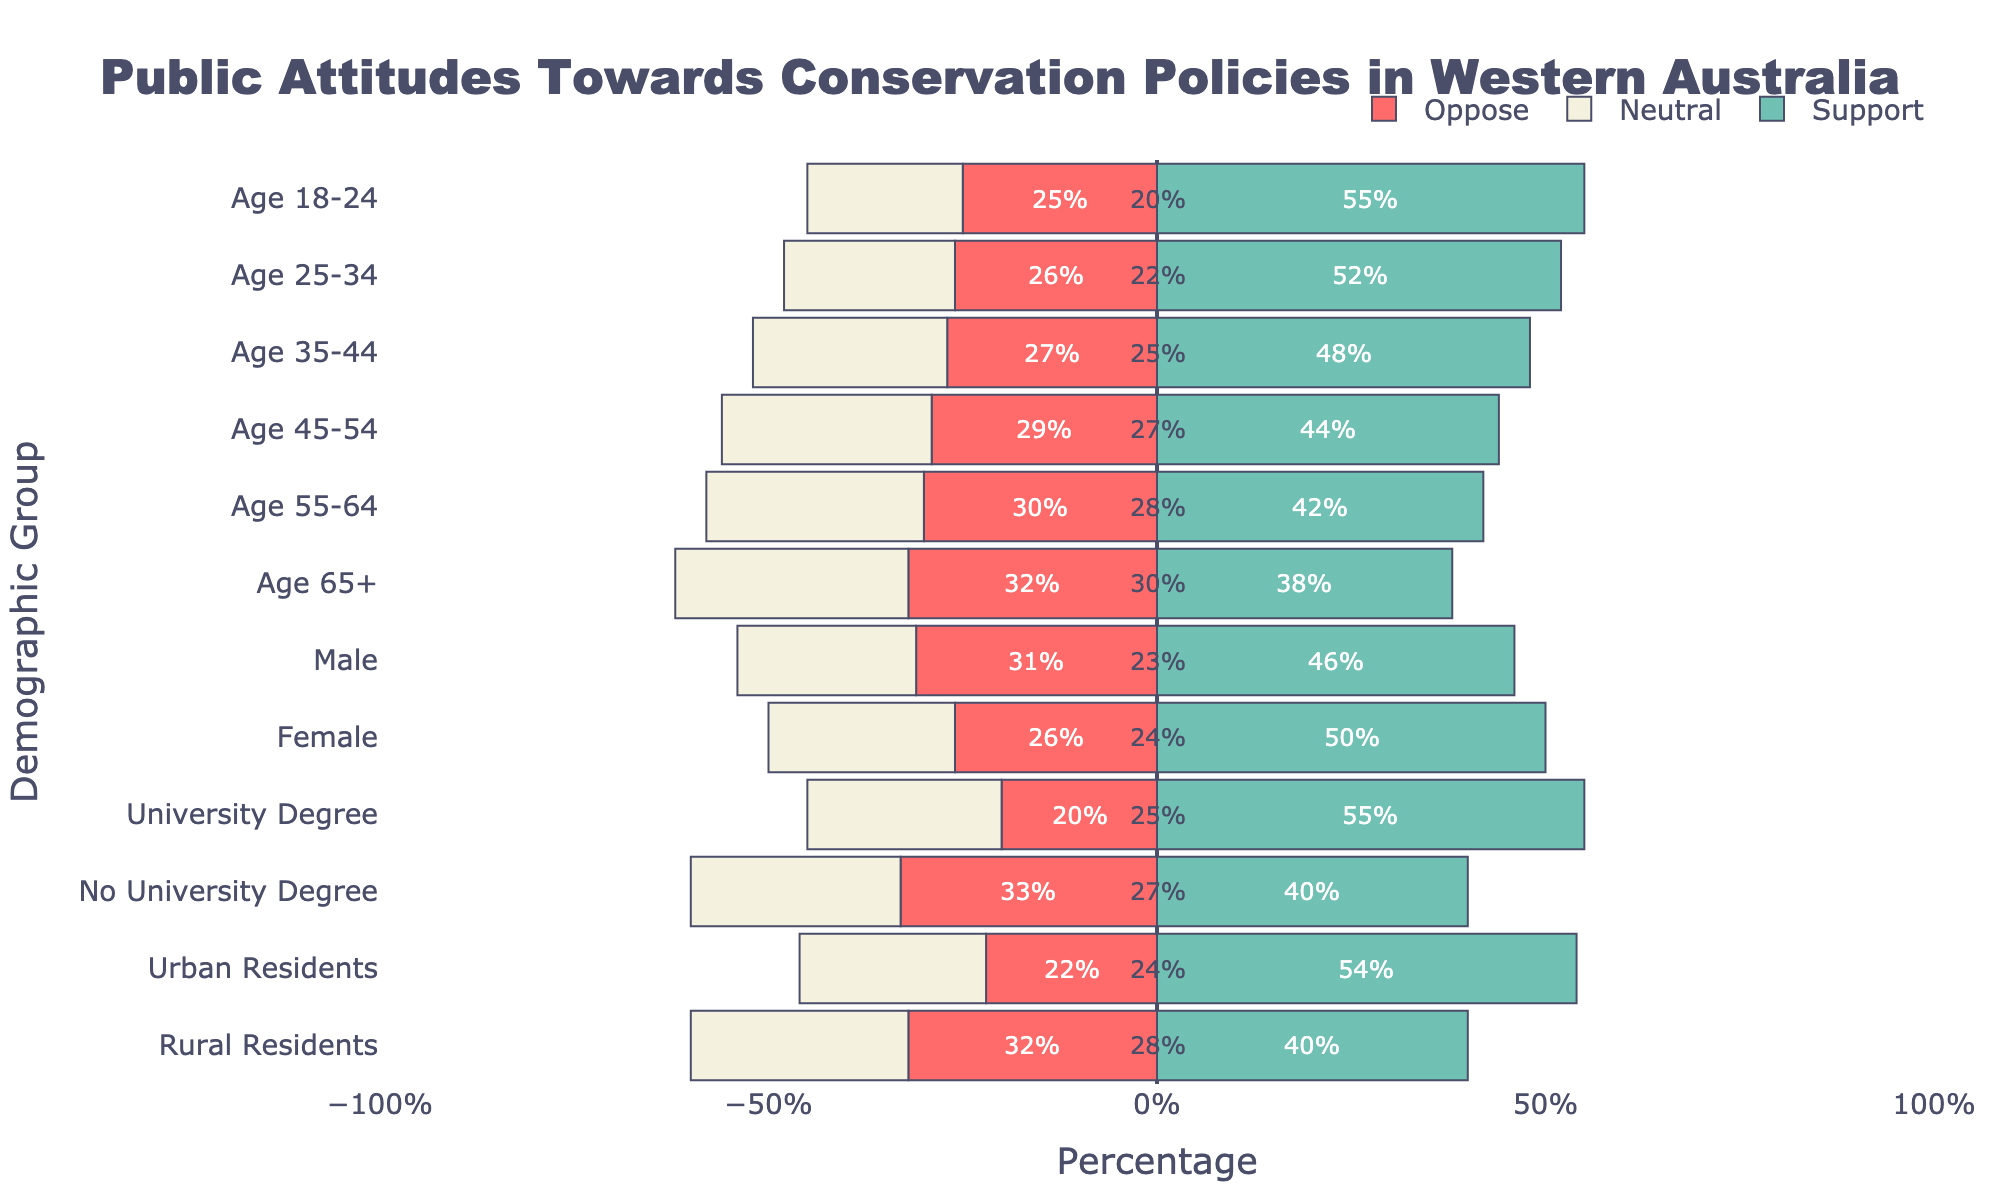What percentage of Urban Residents support conservation policies compared to Rural Residents? Urban Residents have 28% + 26% support = 54%, while Rural Residents have 22% + 18% support = 40%. Therefore, Urban Residents have a higher support percentage.
Answer: Urban: 54%, Rural: 40% Which demographic group has the highest percentage of strong support for conservation policies? By examining the 'Support Strongly' bar for each group, University Degree holders have the highest strong support percentage at 29%.
Answer: University Degree holders What is the overall opposition (somewhat and strongly combined) percentage for the 65+ age group? The 65+ age group shows 20% opposition somewhat and 12% opposition strongly, making the overall opposition 20% + 12% = 32%.
Answer: 32% Which gender group has higher neutral attitudes towards conservation policies? Neutral attitudes for males are 23%, while for females it's 24%. Therefore, females have a slightly higher neutral percentage.
Answer: Females Calculate the average support percentage across all age groups. Sum of support (Strongly + Somewhat) for each age group is 55% + 52% + 48% + 44% + 42% + 38%. The average is (55 + 52 + 48 + 44 + 42 + 38) / 6 = 46.5%.
Answer: 46.5% Summarize the opposition attitude of individuals with no university degrees compared to those with a university degree. No University Degree holders show 20% oppose somewhat + 13% oppose strongly = 33%. University Degree holders show 13% + 7% = 20%. Therefore, No University Degree holders show higher opposition.
Answer: No University Degree: 33%, University Degree: 20% Which demographic group has the largest neutral attitude towards conservation policies? By looking at the length of the 'Neutral' bar, the 65+ age group has the highest neutral attitude at 30%.
Answer: Age 65+ How much more strongly does the 18-24 age group support conservation policies compared to the 45-54 age group? The 18-24 age group strongly supports by 30%, while the 45-54 age group by 23%. The difference is 30% - 23% = 7%.
Answer: 7% What can be inferred about the opposition towards conservation policies in urban versus rural residents? Urban residents have 14% oppose somewhat + 8% oppose strongly = 22% total opposition, while Rural residents have 19% + 13% = 32%. Consequently, Rural residents show higher opposition.
Answer: Urban: 22%, Rural: 32% 